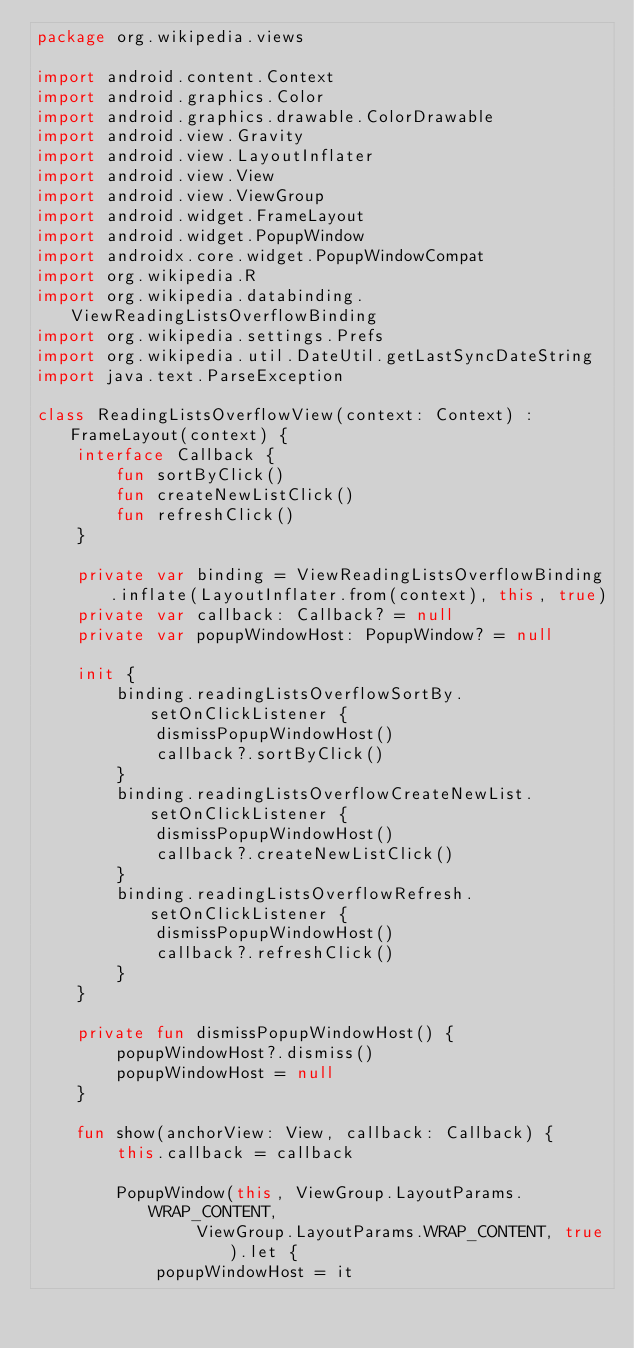Convert code to text. <code><loc_0><loc_0><loc_500><loc_500><_Kotlin_>package org.wikipedia.views

import android.content.Context
import android.graphics.Color
import android.graphics.drawable.ColorDrawable
import android.view.Gravity
import android.view.LayoutInflater
import android.view.View
import android.view.ViewGroup
import android.widget.FrameLayout
import android.widget.PopupWindow
import androidx.core.widget.PopupWindowCompat
import org.wikipedia.R
import org.wikipedia.databinding.ViewReadingListsOverflowBinding
import org.wikipedia.settings.Prefs
import org.wikipedia.util.DateUtil.getLastSyncDateString
import java.text.ParseException

class ReadingListsOverflowView(context: Context) : FrameLayout(context) {
    interface Callback {
        fun sortByClick()
        fun createNewListClick()
        fun refreshClick()
    }

    private var binding = ViewReadingListsOverflowBinding.inflate(LayoutInflater.from(context), this, true)
    private var callback: Callback? = null
    private var popupWindowHost: PopupWindow? = null

    init {
        binding.readingListsOverflowSortBy.setOnClickListener {
            dismissPopupWindowHost()
            callback?.sortByClick()
        }
        binding.readingListsOverflowCreateNewList.setOnClickListener {
            dismissPopupWindowHost()
            callback?.createNewListClick()
        }
        binding.readingListsOverflowRefresh.setOnClickListener {
            dismissPopupWindowHost()
            callback?.refreshClick()
        }
    }

    private fun dismissPopupWindowHost() {
        popupWindowHost?.dismiss()
        popupWindowHost = null
    }

    fun show(anchorView: View, callback: Callback) {
        this.callback = callback

        PopupWindow(this, ViewGroup.LayoutParams.WRAP_CONTENT,
                ViewGroup.LayoutParams.WRAP_CONTENT, true).let {
            popupWindowHost = it</code> 